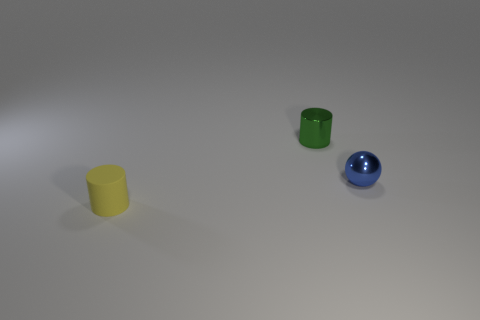Add 2 green cylinders. How many objects exist? 5 Subtract all cylinders. How many objects are left? 1 Subtract 0 cyan balls. How many objects are left? 3 Subtract all blue cylinders. Subtract all yellow cylinders. How many objects are left? 2 Add 2 tiny yellow objects. How many tiny yellow objects are left? 3 Add 2 tiny blue balls. How many tiny blue balls exist? 3 